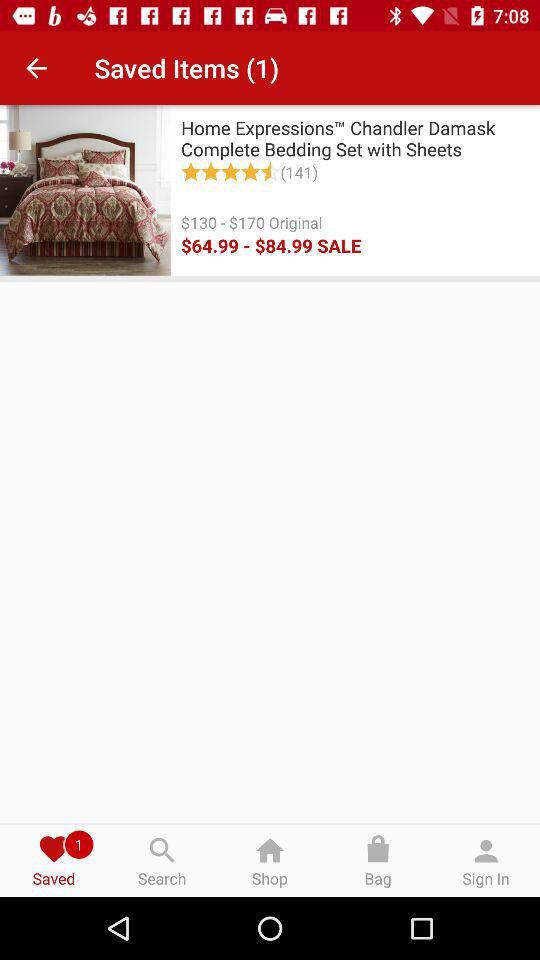What is the original price range of the bedding set? The original price range is $130 to $170. 